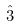<formula> <loc_0><loc_0><loc_500><loc_500>\hat { 3 }</formula> 